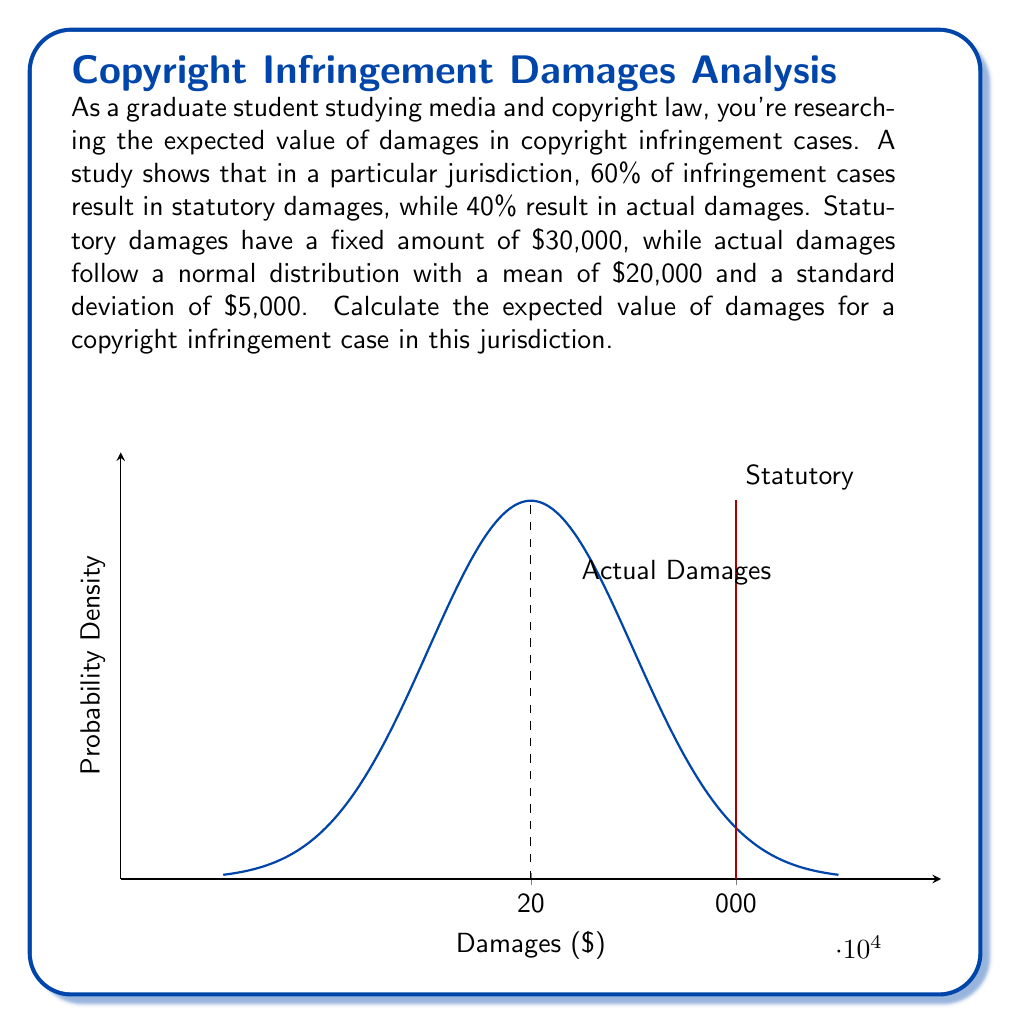Show me your answer to this math problem. Let's approach this step-by-step:

1) First, we need to understand the concept of expected value. The expected value is calculated by multiplying each possible outcome by its probability and then summing these products.

2) In this case, we have two possible outcomes: statutory damages and actual damages.

3) For statutory damages:
   - Probability: 60% = 0.6
   - Amount: $30,000
   - Contribution to expected value: $0.6 \times 30,000 = $18,000$

4) For actual damages:
   - Probability: 40% = 0.4
   - Amount: Normally distributed with mean $\mu = $20,000$ and standard deviation $\sigma = $5,000$
   - For a normal distribution, the expected value is equal to the mean
   - Contribution to expected value: $0.4 \times 20,000 = $8,000$

5) The total expected value is the sum of these two contributions:

   $$E(\text{damages}) = (0.6 \times 30,000) + (0.4 \times 20,000)$$
   $$E(\text{damages}) = 18,000 + 8,000 = $26,000$$

Therefore, the expected value of damages for a copyright infringement case in this jurisdiction is $26,000.
Answer: $26,000 